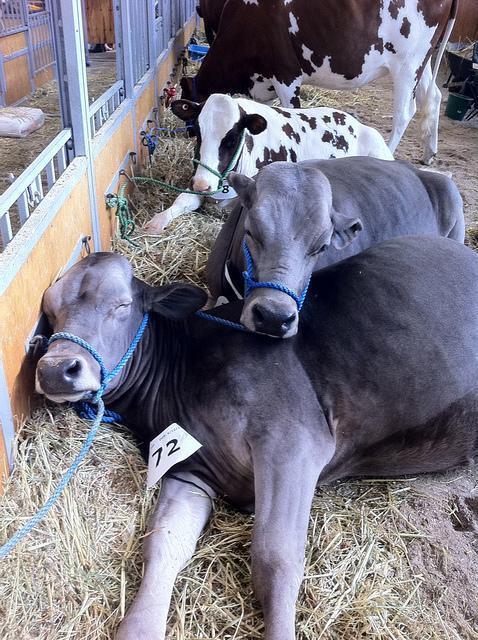How many cows are in this picture?
Give a very brief answer. 4. How many cows can be seen?
Give a very brief answer. 4. How many giraffes can you see in the picture?
Give a very brief answer. 0. 